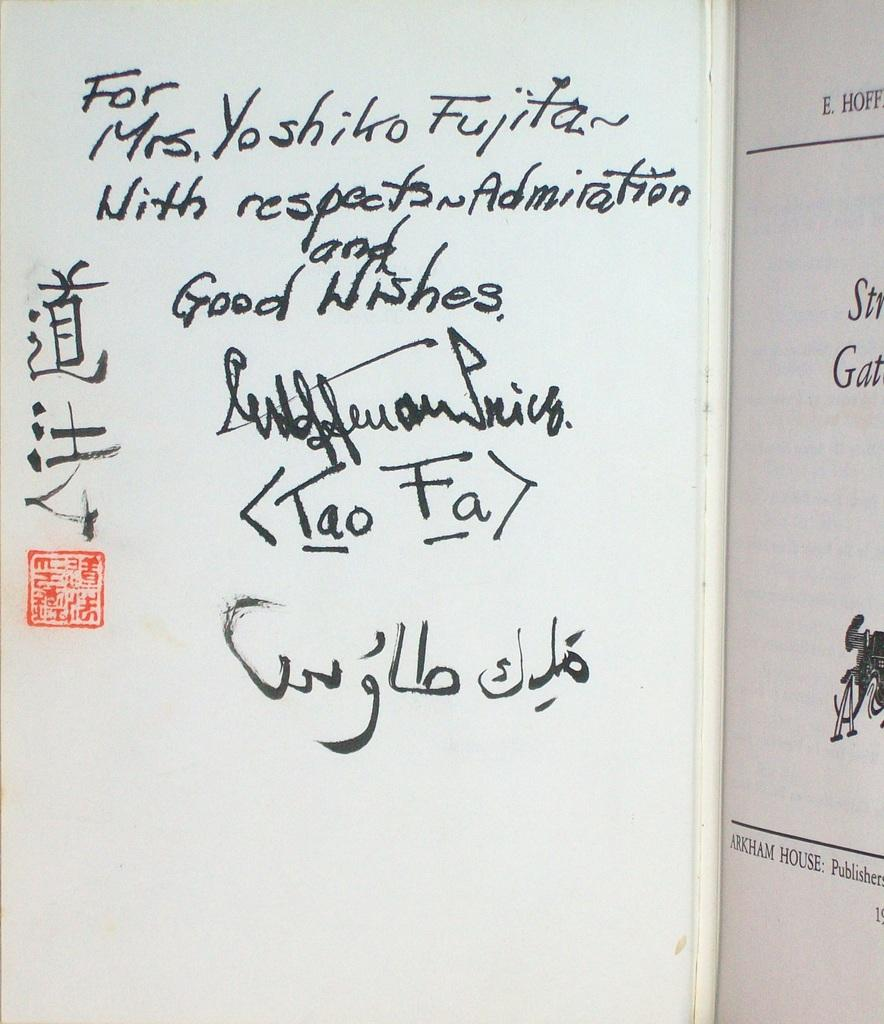<image>
Offer a succinct explanation of the picture presented. A white board with some foreign symbols and a "Good Wishes" letter. 